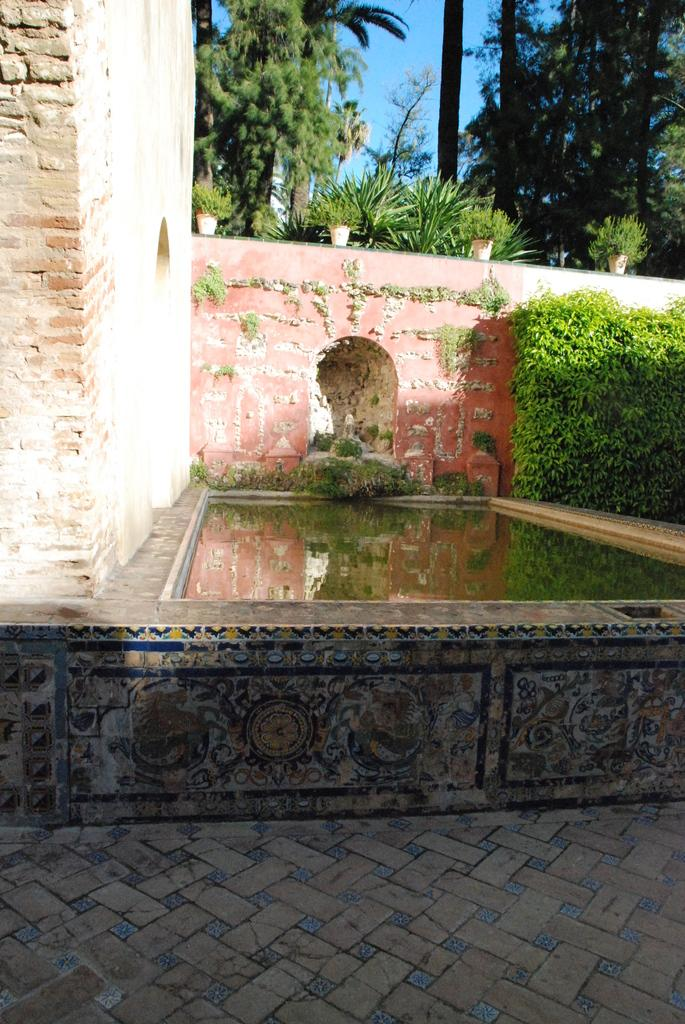What is the primary element present in the image? The image contains water. What type of structure can be seen in the image? There is a wall in the image. What type of vegetation is present in the image? There are plants in the image. What can be seen in the background of the image? There are trees and the sky visible in the background of the image. How does the sleet affect the plants in the image? There is no sleet present in the image; it only contains water. Can you describe the movement of the trees in the image? The trees are not moving in the image; they are stationary. 